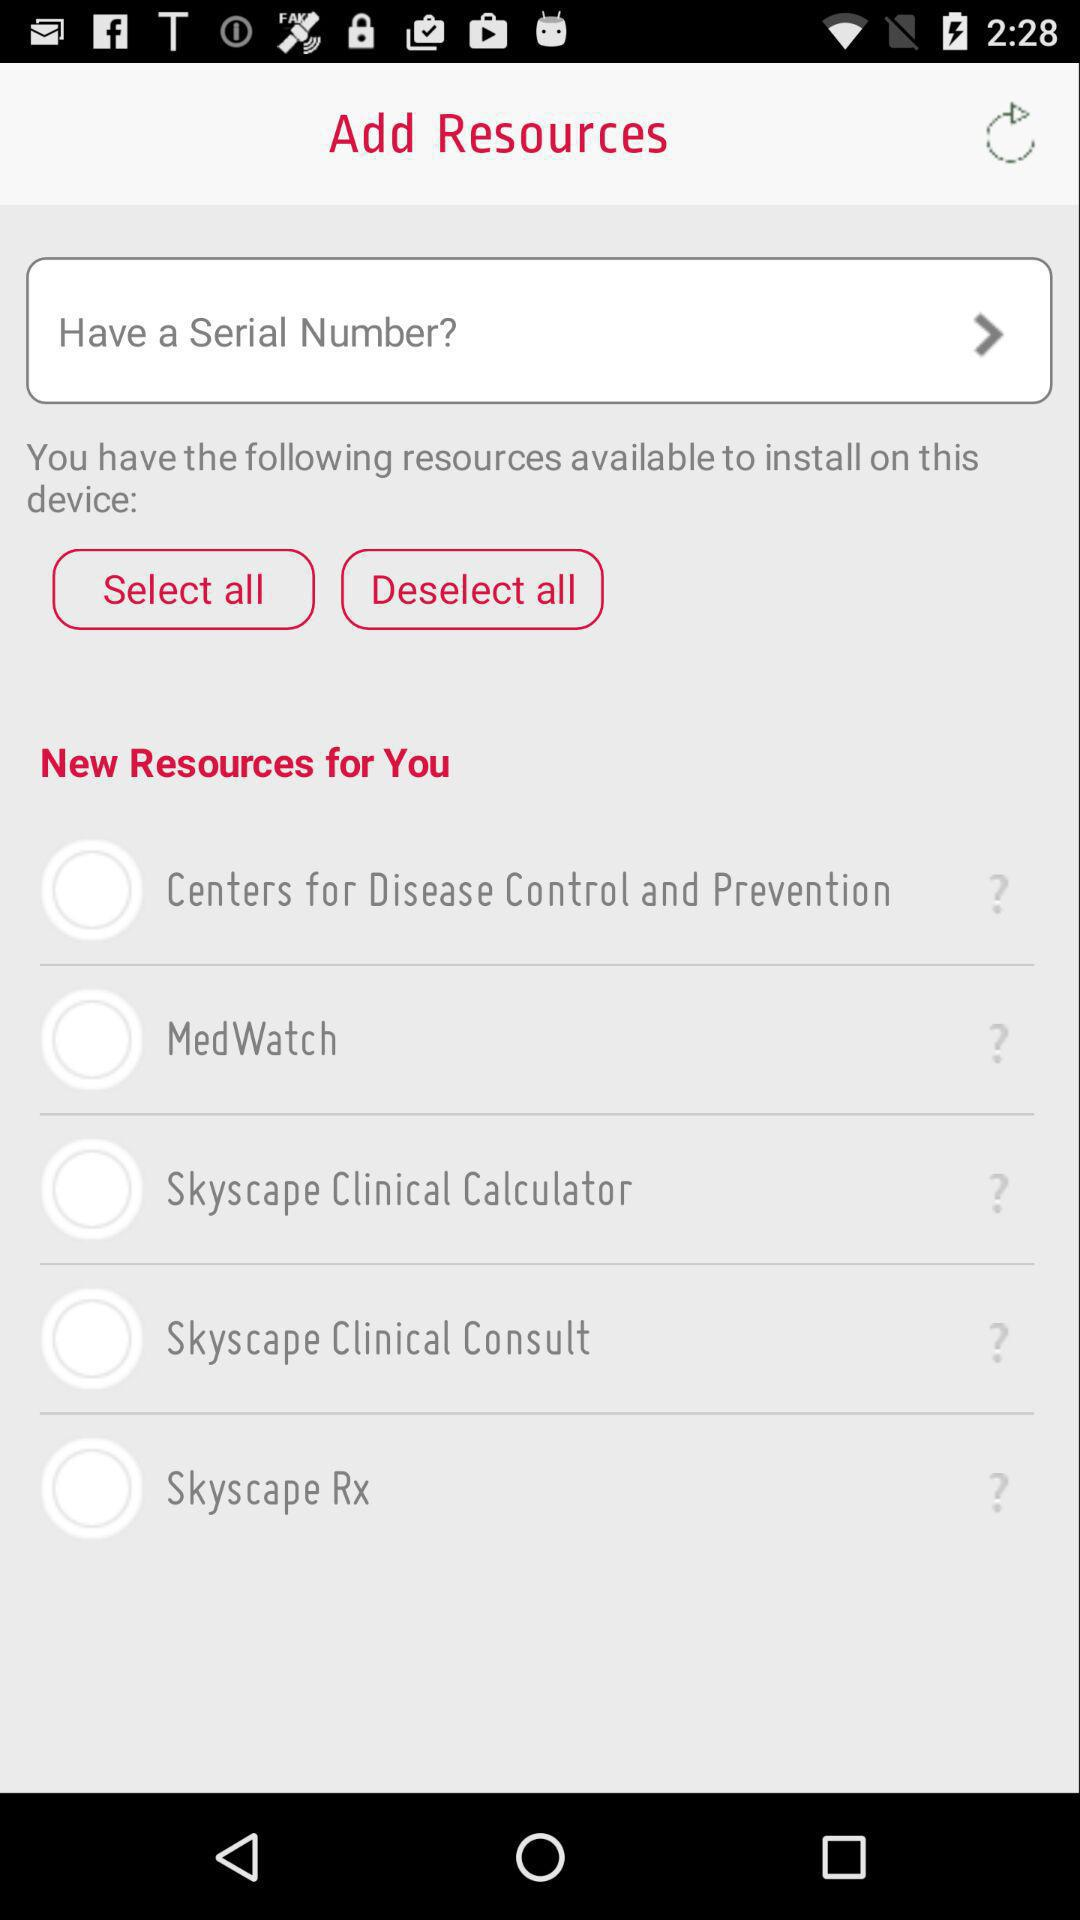How many resources are currently selected?
Answer the question using a single word or phrase. 0 